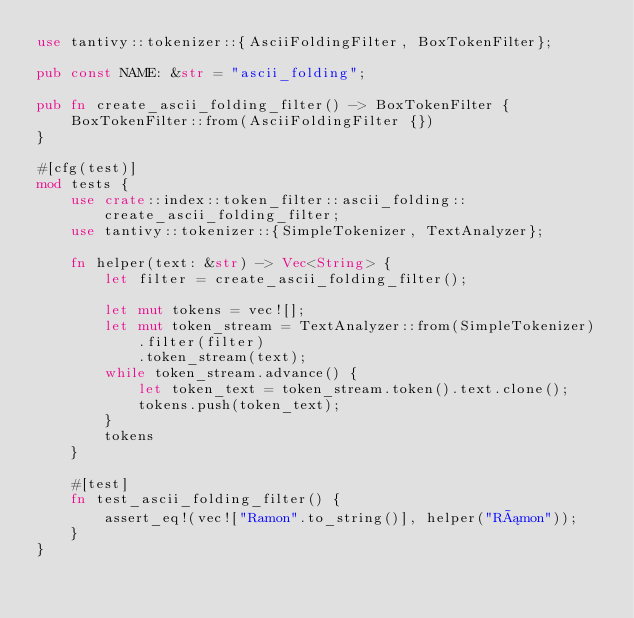Convert code to text. <code><loc_0><loc_0><loc_500><loc_500><_Rust_>use tantivy::tokenizer::{AsciiFoldingFilter, BoxTokenFilter};

pub const NAME: &str = "ascii_folding";

pub fn create_ascii_folding_filter() -> BoxTokenFilter {
    BoxTokenFilter::from(AsciiFoldingFilter {})
}

#[cfg(test)]
mod tests {
    use crate::index::token_filter::ascii_folding::create_ascii_folding_filter;
    use tantivy::tokenizer::{SimpleTokenizer, TextAnalyzer};

    fn helper(text: &str) -> Vec<String> {
        let filter = create_ascii_folding_filter();

        let mut tokens = vec![];
        let mut token_stream = TextAnalyzer::from(SimpleTokenizer)
            .filter(filter)
            .token_stream(text);
        while token_stream.advance() {
            let token_text = token_stream.token().text.clone();
            tokens.push(token_text);
        }
        tokens
    }

    #[test]
    fn test_ascii_folding_filter() {
        assert_eq!(vec!["Ramon".to_string()], helper("Rámon"));
    }
}
</code> 